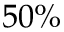<formula> <loc_0><loc_0><loc_500><loc_500>5 0 \%</formula> 